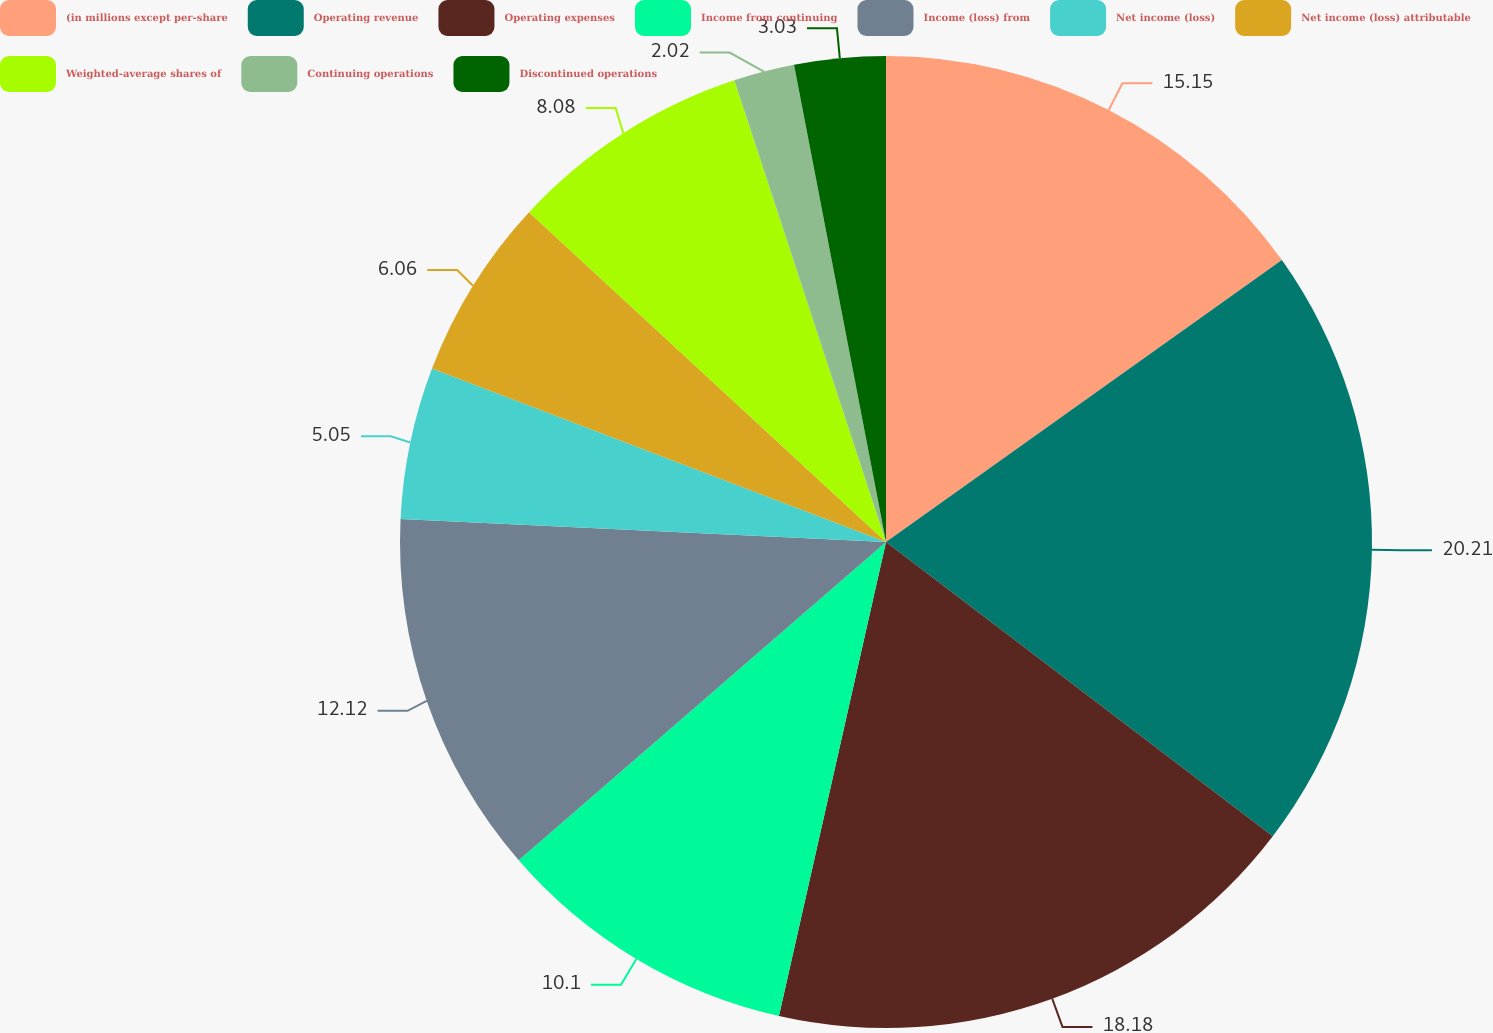<chart> <loc_0><loc_0><loc_500><loc_500><pie_chart><fcel>(in millions except per-share<fcel>Operating revenue<fcel>Operating expenses<fcel>Income from continuing<fcel>Income (loss) from<fcel>Net income (loss)<fcel>Net income (loss) attributable<fcel>Weighted-average shares of<fcel>Continuing operations<fcel>Discontinued operations<nl><fcel>15.15%<fcel>20.2%<fcel>18.18%<fcel>10.1%<fcel>12.12%<fcel>5.05%<fcel>6.06%<fcel>8.08%<fcel>2.02%<fcel>3.03%<nl></chart> 